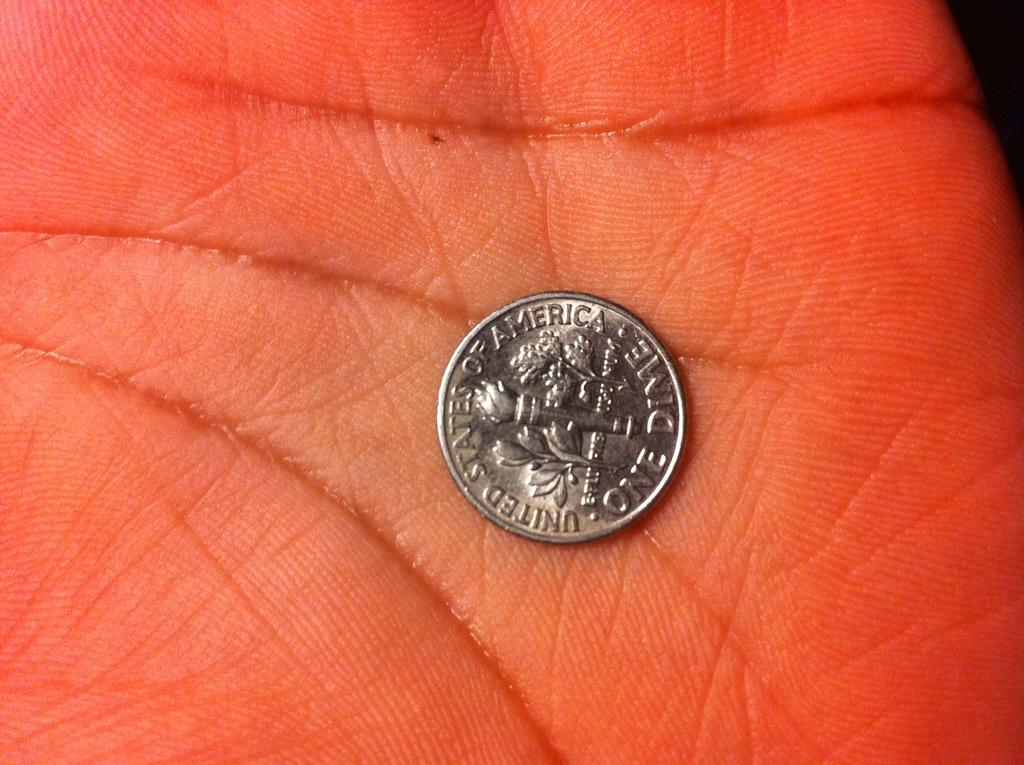<image>
Relay a brief, clear account of the picture shown. A hand holds United States of America Dime in the palm. 